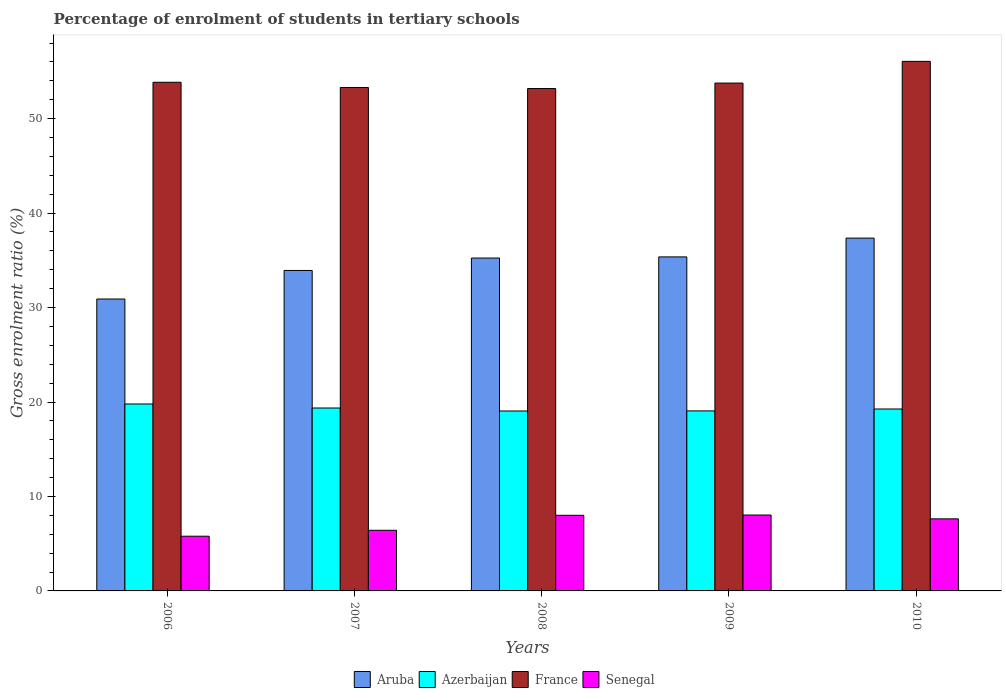How many different coloured bars are there?
Your answer should be compact. 4. How many groups of bars are there?
Offer a terse response. 5. Are the number of bars per tick equal to the number of legend labels?
Offer a very short reply. Yes. How many bars are there on the 1st tick from the left?
Give a very brief answer. 4. What is the label of the 5th group of bars from the left?
Your answer should be compact. 2010. In how many cases, is the number of bars for a given year not equal to the number of legend labels?
Your answer should be compact. 0. What is the percentage of students enrolled in tertiary schools in Senegal in 2008?
Your answer should be very brief. 8. Across all years, what is the maximum percentage of students enrolled in tertiary schools in Azerbaijan?
Your answer should be very brief. 19.79. Across all years, what is the minimum percentage of students enrolled in tertiary schools in Azerbaijan?
Offer a terse response. 19.05. What is the total percentage of students enrolled in tertiary schools in Aruba in the graph?
Make the answer very short. 172.78. What is the difference between the percentage of students enrolled in tertiary schools in Aruba in 2006 and that in 2008?
Provide a succinct answer. -4.34. What is the difference between the percentage of students enrolled in tertiary schools in Aruba in 2009 and the percentage of students enrolled in tertiary schools in Senegal in 2006?
Your response must be concise. 29.57. What is the average percentage of students enrolled in tertiary schools in Senegal per year?
Your answer should be very brief. 7.18. In the year 2007, what is the difference between the percentage of students enrolled in tertiary schools in Senegal and percentage of students enrolled in tertiary schools in France?
Provide a succinct answer. -46.88. What is the ratio of the percentage of students enrolled in tertiary schools in Azerbaijan in 2006 to that in 2007?
Provide a short and direct response. 1.02. Is the difference between the percentage of students enrolled in tertiary schools in Senegal in 2008 and 2009 greater than the difference between the percentage of students enrolled in tertiary schools in France in 2008 and 2009?
Ensure brevity in your answer.  Yes. What is the difference between the highest and the second highest percentage of students enrolled in tertiary schools in Aruba?
Your response must be concise. 1.99. What is the difference between the highest and the lowest percentage of students enrolled in tertiary schools in Aruba?
Keep it short and to the point. 6.45. In how many years, is the percentage of students enrolled in tertiary schools in Aruba greater than the average percentage of students enrolled in tertiary schools in Aruba taken over all years?
Keep it short and to the point. 3. Is the sum of the percentage of students enrolled in tertiary schools in Azerbaijan in 2009 and 2010 greater than the maximum percentage of students enrolled in tertiary schools in France across all years?
Offer a very short reply. No. What does the 4th bar from the left in 2008 represents?
Your answer should be compact. Senegal. What does the 4th bar from the right in 2010 represents?
Your answer should be very brief. Aruba. Is it the case that in every year, the sum of the percentage of students enrolled in tertiary schools in Azerbaijan and percentage of students enrolled in tertiary schools in France is greater than the percentage of students enrolled in tertiary schools in Aruba?
Your answer should be compact. Yes. Are all the bars in the graph horizontal?
Offer a terse response. No. What is the difference between two consecutive major ticks on the Y-axis?
Make the answer very short. 10. Are the values on the major ticks of Y-axis written in scientific E-notation?
Offer a terse response. No. Does the graph contain any zero values?
Provide a short and direct response. No. Does the graph contain grids?
Make the answer very short. No. What is the title of the graph?
Provide a short and direct response. Percentage of enrolment of students in tertiary schools. What is the label or title of the X-axis?
Ensure brevity in your answer.  Years. What is the label or title of the Y-axis?
Give a very brief answer. Gross enrolment ratio (%). What is the Gross enrolment ratio (%) in Aruba in 2006?
Give a very brief answer. 30.9. What is the Gross enrolment ratio (%) in Azerbaijan in 2006?
Provide a succinct answer. 19.79. What is the Gross enrolment ratio (%) of France in 2006?
Offer a terse response. 53.85. What is the Gross enrolment ratio (%) in Senegal in 2006?
Your answer should be very brief. 5.79. What is the Gross enrolment ratio (%) of Aruba in 2007?
Offer a very short reply. 33.93. What is the Gross enrolment ratio (%) of Azerbaijan in 2007?
Make the answer very short. 19.36. What is the Gross enrolment ratio (%) in France in 2007?
Keep it short and to the point. 53.3. What is the Gross enrolment ratio (%) in Senegal in 2007?
Keep it short and to the point. 6.42. What is the Gross enrolment ratio (%) of Aruba in 2008?
Provide a succinct answer. 35.24. What is the Gross enrolment ratio (%) in Azerbaijan in 2008?
Provide a short and direct response. 19.05. What is the Gross enrolment ratio (%) in France in 2008?
Make the answer very short. 53.19. What is the Gross enrolment ratio (%) of Senegal in 2008?
Offer a very short reply. 8. What is the Gross enrolment ratio (%) in Aruba in 2009?
Offer a very short reply. 35.36. What is the Gross enrolment ratio (%) in Azerbaijan in 2009?
Make the answer very short. 19.06. What is the Gross enrolment ratio (%) of France in 2009?
Make the answer very short. 53.76. What is the Gross enrolment ratio (%) in Senegal in 2009?
Provide a short and direct response. 8.04. What is the Gross enrolment ratio (%) of Aruba in 2010?
Give a very brief answer. 37.35. What is the Gross enrolment ratio (%) of Azerbaijan in 2010?
Offer a terse response. 19.26. What is the Gross enrolment ratio (%) in France in 2010?
Give a very brief answer. 56.06. What is the Gross enrolment ratio (%) of Senegal in 2010?
Give a very brief answer. 7.63. Across all years, what is the maximum Gross enrolment ratio (%) of Aruba?
Your response must be concise. 37.35. Across all years, what is the maximum Gross enrolment ratio (%) of Azerbaijan?
Provide a succinct answer. 19.79. Across all years, what is the maximum Gross enrolment ratio (%) of France?
Provide a short and direct response. 56.06. Across all years, what is the maximum Gross enrolment ratio (%) of Senegal?
Give a very brief answer. 8.04. Across all years, what is the minimum Gross enrolment ratio (%) of Aruba?
Your answer should be very brief. 30.9. Across all years, what is the minimum Gross enrolment ratio (%) of Azerbaijan?
Provide a short and direct response. 19.05. Across all years, what is the minimum Gross enrolment ratio (%) in France?
Keep it short and to the point. 53.19. Across all years, what is the minimum Gross enrolment ratio (%) in Senegal?
Provide a short and direct response. 5.79. What is the total Gross enrolment ratio (%) of Aruba in the graph?
Offer a very short reply. 172.78. What is the total Gross enrolment ratio (%) in Azerbaijan in the graph?
Offer a terse response. 96.52. What is the total Gross enrolment ratio (%) in France in the graph?
Provide a succinct answer. 270.16. What is the total Gross enrolment ratio (%) of Senegal in the graph?
Your answer should be very brief. 35.88. What is the difference between the Gross enrolment ratio (%) in Aruba in 2006 and that in 2007?
Your response must be concise. -3.02. What is the difference between the Gross enrolment ratio (%) in Azerbaijan in 2006 and that in 2007?
Your response must be concise. 0.42. What is the difference between the Gross enrolment ratio (%) of France in 2006 and that in 2007?
Provide a short and direct response. 0.55. What is the difference between the Gross enrolment ratio (%) in Senegal in 2006 and that in 2007?
Provide a succinct answer. -0.63. What is the difference between the Gross enrolment ratio (%) of Aruba in 2006 and that in 2008?
Offer a terse response. -4.34. What is the difference between the Gross enrolment ratio (%) of Azerbaijan in 2006 and that in 2008?
Provide a succinct answer. 0.74. What is the difference between the Gross enrolment ratio (%) of France in 2006 and that in 2008?
Make the answer very short. 0.66. What is the difference between the Gross enrolment ratio (%) in Senegal in 2006 and that in 2008?
Offer a very short reply. -2.21. What is the difference between the Gross enrolment ratio (%) of Aruba in 2006 and that in 2009?
Provide a short and direct response. -4.46. What is the difference between the Gross enrolment ratio (%) in Azerbaijan in 2006 and that in 2009?
Provide a succinct answer. 0.73. What is the difference between the Gross enrolment ratio (%) in France in 2006 and that in 2009?
Offer a very short reply. 0.08. What is the difference between the Gross enrolment ratio (%) of Senegal in 2006 and that in 2009?
Provide a short and direct response. -2.24. What is the difference between the Gross enrolment ratio (%) in Aruba in 2006 and that in 2010?
Provide a succinct answer. -6.45. What is the difference between the Gross enrolment ratio (%) of Azerbaijan in 2006 and that in 2010?
Your answer should be very brief. 0.53. What is the difference between the Gross enrolment ratio (%) of France in 2006 and that in 2010?
Your response must be concise. -2.21. What is the difference between the Gross enrolment ratio (%) in Senegal in 2006 and that in 2010?
Provide a short and direct response. -1.84. What is the difference between the Gross enrolment ratio (%) in Aruba in 2007 and that in 2008?
Make the answer very short. -1.31. What is the difference between the Gross enrolment ratio (%) in Azerbaijan in 2007 and that in 2008?
Your answer should be compact. 0.32. What is the difference between the Gross enrolment ratio (%) in France in 2007 and that in 2008?
Offer a terse response. 0.11. What is the difference between the Gross enrolment ratio (%) in Senegal in 2007 and that in 2008?
Give a very brief answer. -1.59. What is the difference between the Gross enrolment ratio (%) in Aruba in 2007 and that in 2009?
Make the answer very short. -1.44. What is the difference between the Gross enrolment ratio (%) in Azerbaijan in 2007 and that in 2009?
Your answer should be compact. 0.31. What is the difference between the Gross enrolment ratio (%) in France in 2007 and that in 2009?
Your answer should be very brief. -0.47. What is the difference between the Gross enrolment ratio (%) in Senegal in 2007 and that in 2009?
Your answer should be compact. -1.62. What is the difference between the Gross enrolment ratio (%) in Aruba in 2007 and that in 2010?
Your answer should be very brief. -3.43. What is the difference between the Gross enrolment ratio (%) of Azerbaijan in 2007 and that in 2010?
Keep it short and to the point. 0.1. What is the difference between the Gross enrolment ratio (%) in France in 2007 and that in 2010?
Keep it short and to the point. -2.77. What is the difference between the Gross enrolment ratio (%) in Senegal in 2007 and that in 2010?
Offer a very short reply. -1.21. What is the difference between the Gross enrolment ratio (%) of Aruba in 2008 and that in 2009?
Offer a terse response. -0.12. What is the difference between the Gross enrolment ratio (%) of Azerbaijan in 2008 and that in 2009?
Offer a very short reply. -0.01. What is the difference between the Gross enrolment ratio (%) in France in 2008 and that in 2009?
Provide a succinct answer. -0.58. What is the difference between the Gross enrolment ratio (%) of Senegal in 2008 and that in 2009?
Your answer should be compact. -0.03. What is the difference between the Gross enrolment ratio (%) in Aruba in 2008 and that in 2010?
Your answer should be compact. -2.11. What is the difference between the Gross enrolment ratio (%) in Azerbaijan in 2008 and that in 2010?
Provide a succinct answer. -0.21. What is the difference between the Gross enrolment ratio (%) in France in 2008 and that in 2010?
Provide a succinct answer. -2.88. What is the difference between the Gross enrolment ratio (%) of Senegal in 2008 and that in 2010?
Your answer should be very brief. 0.37. What is the difference between the Gross enrolment ratio (%) in Aruba in 2009 and that in 2010?
Provide a short and direct response. -1.99. What is the difference between the Gross enrolment ratio (%) in Azerbaijan in 2009 and that in 2010?
Your response must be concise. -0.2. What is the difference between the Gross enrolment ratio (%) in France in 2009 and that in 2010?
Keep it short and to the point. -2.3. What is the difference between the Gross enrolment ratio (%) of Senegal in 2009 and that in 2010?
Ensure brevity in your answer.  0.41. What is the difference between the Gross enrolment ratio (%) of Aruba in 2006 and the Gross enrolment ratio (%) of Azerbaijan in 2007?
Keep it short and to the point. 11.54. What is the difference between the Gross enrolment ratio (%) in Aruba in 2006 and the Gross enrolment ratio (%) in France in 2007?
Ensure brevity in your answer.  -22.39. What is the difference between the Gross enrolment ratio (%) in Aruba in 2006 and the Gross enrolment ratio (%) in Senegal in 2007?
Keep it short and to the point. 24.48. What is the difference between the Gross enrolment ratio (%) of Azerbaijan in 2006 and the Gross enrolment ratio (%) of France in 2007?
Provide a short and direct response. -33.51. What is the difference between the Gross enrolment ratio (%) in Azerbaijan in 2006 and the Gross enrolment ratio (%) in Senegal in 2007?
Ensure brevity in your answer.  13.37. What is the difference between the Gross enrolment ratio (%) in France in 2006 and the Gross enrolment ratio (%) in Senegal in 2007?
Your answer should be very brief. 47.43. What is the difference between the Gross enrolment ratio (%) of Aruba in 2006 and the Gross enrolment ratio (%) of Azerbaijan in 2008?
Provide a short and direct response. 11.86. What is the difference between the Gross enrolment ratio (%) in Aruba in 2006 and the Gross enrolment ratio (%) in France in 2008?
Ensure brevity in your answer.  -22.28. What is the difference between the Gross enrolment ratio (%) in Aruba in 2006 and the Gross enrolment ratio (%) in Senegal in 2008?
Keep it short and to the point. 22.9. What is the difference between the Gross enrolment ratio (%) of Azerbaijan in 2006 and the Gross enrolment ratio (%) of France in 2008?
Offer a very short reply. -33.4. What is the difference between the Gross enrolment ratio (%) in Azerbaijan in 2006 and the Gross enrolment ratio (%) in Senegal in 2008?
Your response must be concise. 11.78. What is the difference between the Gross enrolment ratio (%) of France in 2006 and the Gross enrolment ratio (%) of Senegal in 2008?
Your response must be concise. 45.84. What is the difference between the Gross enrolment ratio (%) of Aruba in 2006 and the Gross enrolment ratio (%) of Azerbaijan in 2009?
Your response must be concise. 11.85. What is the difference between the Gross enrolment ratio (%) in Aruba in 2006 and the Gross enrolment ratio (%) in France in 2009?
Offer a very short reply. -22.86. What is the difference between the Gross enrolment ratio (%) in Aruba in 2006 and the Gross enrolment ratio (%) in Senegal in 2009?
Provide a succinct answer. 22.87. What is the difference between the Gross enrolment ratio (%) in Azerbaijan in 2006 and the Gross enrolment ratio (%) in France in 2009?
Give a very brief answer. -33.97. What is the difference between the Gross enrolment ratio (%) in Azerbaijan in 2006 and the Gross enrolment ratio (%) in Senegal in 2009?
Provide a succinct answer. 11.75. What is the difference between the Gross enrolment ratio (%) in France in 2006 and the Gross enrolment ratio (%) in Senegal in 2009?
Give a very brief answer. 45.81. What is the difference between the Gross enrolment ratio (%) of Aruba in 2006 and the Gross enrolment ratio (%) of Azerbaijan in 2010?
Your answer should be very brief. 11.64. What is the difference between the Gross enrolment ratio (%) of Aruba in 2006 and the Gross enrolment ratio (%) of France in 2010?
Keep it short and to the point. -25.16. What is the difference between the Gross enrolment ratio (%) of Aruba in 2006 and the Gross enrolment ratio (%) of Senegal in 2010?
Make the answer very short. 23.27. What is the difference between the Gross enrolment ratio (%) in Azerbaijan in 2006 and the Gross enrolment ratio (%) in France in 2010?
Provide a short and direct response. -36.27. What is the difference between the Gross enrolment ratio (%) in Azerbaijan in 2006 and the Gross enrolment ratio (%) in Senegal in 2010?
Give a very brief answer. 12.16. What is the difference between the Gross enrolment ratio (%) of France in 2006 and the Gross enrolment ratio (%) of Senegal in 2010?
Your answer should be compact. 46.22. What is the difference between the Gross enrolment ratio (%) in Aruba in 2007 and the Gross enrolment ratio (%) in Azerbaijan in 2008?
Your answer should be compact. 14.88. What is the difference between the Gross enrolment ratio (%) of Aruba in 2007 and the Gross enrolment ratio (%) of France in 2008?
Your response must be concise. -19.26. What is the difference between the Gross enrolment ratio (%) in Aruba in 2007 and the Gross enrolment ratio (%) in Senegal in 2008?
Your answer should be compact. 25.92. What is the difference between the Gross enrolment ratio (%) in Azerbaijan in 2007 and the Gross enrolment ratio (%) in France in 2008?
Your answer should be very brief. -33.82. What is the difference between the Gross enrolment ratio (%) in Azerbaijan in 2007 and the Gross enrolment ratio (%) in Senegal in 2008?
Your answer should be compact. 11.36. What is the difference between the Gross enrolment ratio (%) in France in 2007 and the Gross enrolment ratio (%) in Senegal in 2008?
Your answer should be compact. 45.29. What is the difference between the Gross enrolment ratio (%) in Aruba in 2007 and the Gross enrolment ratio (%) in Azerbaijan in 2009?
Ensure brevity in your answer.  14.87. What is the difference between the Gross enrolment ratio (%) in Aruba in 2007 and the Gross enrolment ratio (%) in France in 2009?
Your response must be concise. -19.84. What is the difference between the Gross enrolment ratio (%) in Aruba in 2007 and the Gross enrolment ratio (%) in Senegal in 2009?
Your response must be concise. 25.89. What is the difference between the Gross enrolment ratio (%) in Azerbaijan in 2007 and the Gross enrolment ratio (%) in France in 2009?
Offer a very short reply. -34.4. What is the difference between the Gross enrolment ratio (%) in Azerbaijan in 2007 and the Gross enrolment ratio (%) in Senegal in 2009?
Your answer should be compact. 11.33. What is the difference between the Gross enrolment ratio (%) of France in 2007 and the Gross enrolment ratio (%) of Senegal in 2009?
Ensure brevity in your answer.  45.26. What is the difference between the Gross enrolment ratio (%) in Aruba in 2007 and the Gross enrolment ratio (%) in Azerbaijan in 2010?
Make the answer very short. 14.67. What is the difference between the Gross enrolment ratio (%) of Aruba in 2007 and the Gross enrolment ratio (%) of France in 2010?
Your response must be concise. -22.14. What is the difference between the Gross enrolment ratio (%) in Aruba in 2007 and the Gross enrolment ratio (%) in Senegal in 2010?
Give a very brief answer. 26.3. What is the difference between the Gross enrolment ratio (%) in Azerbaijan in 2007 and the Gross enrolment ratio (%) in France in 2010?
Offer a very short reply. -36.7. What is the difference between the Gross enrolment ratio (%) of Azerbaijan in 2007 and the Gross enrolment ratio (%) of Senegal in 2010?
Your response must be concise. 11.73. What is the difference between the Gross enrolment ratio (%) in France in 2007 and the Gross enrolment ratio (%) in Senegal in 2010?
Offer a terse response. 45.67. What is the difference between the Gross enrolment ratio (%) of Aruba in 2008 and the Gross enrolment ratio (%) of Azerbaijan in 2009?
Ensure brevity in your answer.  16.18. What is the difference between the Gross enrolment ratio (%) of Aruba in 2008 and the Gross enrolment ratio (%) of France in 2009?
Your answer should be compact. -18.52. What is the difference between the Gross enrolment ratio (%) of Aruba in 2008 and the Gross enrolment ratio (%) of Senegal in 2009?
Keep it short and to the point. 27.2. What is the difference between the Gross enrolment ratio (%) in Azerbaijan in 2008 and the Gross enrolment ratio (%) in France in 2009?
Offer a very short reply. -34.72. What is the difference between the Gross enrolment ratio (%) in Azerbaijan in 2008 and the Gross enrolment ratio (%) in Senegal in 2009?
Keep it short and to the point. 11.01. What is the difference between the Gross enrolment ratio (%) of France in 2008 and the Gross enrolment ratio (%) of Senegal in 2009?
Offer a terse response. 45.15. What is the difference between the Gross enrolment ratio (%) in Aruba in 2008 and the Gross enrolment ratio (%) in Azerbaijan in 2010?
Make the answer very short. 15.98. What is the difference between the Gross enrolment ratio (%) in Aruba in 2008 and the Gross enrolment ratio (%) in France in 2010?
Make the answer very short. -20.82. What is the difference between the Gross enrolment ratio (%) of Aruba in 2008 and the Gross enrolment ratio (%) of Senegal in 2010?
Your answer should be compact. 27.61. What is the difference between the Gross enrolment ratio (%) of Azerbaijan in 2008 and the Gross enrolment ratio (%) of France in 2010?
Offer a terse response. -37.02. What is the difference between the Gross enrolment ratio (%) in Azerbaijan in 2008 and the Gross enrolment ratio (%) in Senegal in 2010?
Provide a short and direct response. 11.42. What is the difference between the Gross enrolment ratio (%) in France in 2008 and the Gross enrolment ratio (%) in Senegal in 2010?
Provide a succinct answer. 45.56. What is the difference between the Gross enrolment ratio (%) in Aruba in 2009 and the Gross enrolment ratio (%) in Azerbaijan in 2010?
Your answer should be very brief. 16.1. What is the difference between the Gross enrolment ratio (%) in Aruba in 2009 and the Gross enrolment ratio (%) in France in 2010?
Your response must be concise. -20.7. What is the difference between the Gross enrolment ratio (%) of Aruba in 2009 and the Gross enrolment ratio (%) of Senegal in 2010?
Offer a very short reply. 27.73. What is the difference between the Gross enrolment ratio (%) in Azerbaijan in 2009 and the Gross enrolment ratio (%) in France in 2010?
Keep it short and to the point. -37.01. What is the difference between the Gross enrolment ratio (%) of Azerbaijan in 2009 and the Gross enrolment ratio (%) of Senegal in 2010?
Offer a terse response. 11.43. What is the difference between the Gross enrolment ratio (%) of France in 2009 and the Gross enrolment ratio (%) of Senegal in 2010?
Your answer should be compact. 46.13. What is the average Gross enrolment ratio (%) in Aruba per year?
Provide a succinct answer. 34.56. What is the average Gross enrolment ratio (%) in Azerbaijan per year?
Provide a succinct answer. 19.3. What is the average Gross enrolment ratio (%) of France per year?
Offer a very short reply. 54.03. What is the average Gross enrolment ratio (%) of Senegal per year?
Offer a terse response. 7.18. In the year 2006, what is the difference between the Gross enrolment ratio (%) in Aruba and Gross enrolment ratio (%) in Azerbaijan?
Provide a short and direct response. 11.11. In the year 2006, what is the difference between the Gross enrolment ratio (%) in Aruba and Gross enrolment ratio (%) in France?
Ensure brevity in your answer.  -22.95. In the year 2006, what is the difference between the Gross enrolment ratio (%) of Aruba and Gross enrolment ratio (%) of Senegal?
Provide a short and direct response. 25.11. In the year 2006, what is the difference between the Gross enrolment ratio (%) in Azerbaijan and Gross enrolment ratio (%) in France?
Ensure brevity in your answer.  -34.06. In the year 2006, what is the difference between the Gross enrolment ratio (%) of Azerbaijan and Gross enrolment ratio (%) of Senegal?
Your response must be concise. 14. In the year 2006, what is the difference between the Gross enrolment ratio (%) in France and Gross enrolment ratio (%) in Senegal?
Your answer should be compact. 48.06. In the year 2007, what is the difference between the Gross enrolment ratio (%) of Aruba and Gross enrolment ratio (%) of Azerbaijan?
Provide a short and direct response. 14.56. In the year 2007, what is the difference between the Gross enrolment ratio (%) of Aruba and Gross enrolment ratio (%) of France?
Give a very brief answer. -19.37. In the year 2007, what is the difference between the Gross enrolment ratio (%) in Aruba and Gross enrolment ratio (%) in Senegal?
Offer a very short reply. 27.51. In the year 2007, what is the difference between the Gross enrolment ratio (%) of Azerbaijan and Gross enrolment ratio (%) of France?
Keep it short and to the point. -33.93. In the year 2007, what is the difference between the Gross enrolment ratio (%) in Azerbaijan and Gross enrolment ratio (%) in Senegal?
Offer a very short reply. 12.95. In the year 2007, what is the difference between the Gross enrolment ratio (%) in France and Gross enrolment ratio (%) in Senegal?
Offer a very short reply. 46.88. In the year 2008, what is the difference between the Gross enrolment ratio (%) of Aruba and Gross enrolment ratio (%) of Azerbaijan?
Make the answer very short. 16.19. In the year 2008, what is the difference between the Gross enrolment ratio (%) of Aruba and Gross enrolment ratio (%) of France?
Provide a short and direct response. -17.95. In the year 2008, what is the difference between the Gross enrolment ratio (%) of Aruba and Gross enrolment ratio (%) of Senegal?
Offer a terse response. 27.24. In the year 2008, what is the difference between the Gross enrolment ratio (%) in Azerbaijan and Gross enrolment ratio (%) in France?
Give a very brief answer. -34.14. In the year 2008, what is the difference between the Gross enrolment ratio (%) in Azerbaijan and Gross enrolment ratio (%) in Senegal?
Your answer should be very brief. 11.04. In the year 2008, what is the difference between the Gross enrolment ratio (%) in France and Gross enrolment ratio (%) in Senegal?
Your answer should be compact. 45.18. In the year 2009, what is the difference between the Gross enrolment ratio (%) in Aruba and Gross enrolment ratio (%) in Azerbaijan?
Keep it short and to the point. 16.3. In the year 2009, what is the difference between the Gross enrolment ratio (%) of Aruba and Gross enrolment ratio (%) of France?
Offer a very short reply. -18.4. In the year 2009, what is the difference between the Gross enrolment ratio (%) of Aruba and Gross enrolment ratio (%) of Senegal?
Offer a very short reply. 27.33. In the year 2009, what is the difference between the Gross enrolment ratio (%) of Azerbaijan and Gross enrolment ratio (%) of France?
Offer a very short reply. -34.71. In the year 2009, what is the difference between the Gross enrolment ratio (%) of Azerbaijan and Gross enrolment ratio (%) of Senegal?
Ensure brevity in your answer.  11.02. In the year 2009, what is the difference between the Gross enrolment ratio (%) of France and Gross enrolment ratio (%) of Senegal?
Offer a very short reply. 45.73. In the year 2010, what is the difference between the Gross enrolment ratio (%) in Aruba and Gross enrolment ratio (%) in Azerbaijan?
Offer a terse response. 18.09. In the year 2010, what is the difference between the Gross enrolment ratio (%) in Aruba and Gross enrolment ratio (%) in France?
Your answer should be very brief. -18.71. In the year 2010, what is the difference between the Gross enrolment ratio (%) of Aruba and Gross enrolment ratio (%) of Senegal?
Ensure brevity in your answer.  29.72. In the year 2010, what is the difference between the Gross enrolment ratio (%) of Azerbaijan and Gross enrolment ratio (%) of France?
Provide a short and direct response. -36.8. In the year 2010, what is the difference between the Gross enrolment ratio (%) of Azerbaijan and Gross enrolment ratio (%) of Senegal?
Give a very brief answer. 11.63. In the year 2010, what is the difference between the Gross enrolment ratio (%) in France and Gross enrolment ratio (%) in Senegal?
Offer a very short reply. 48.43. What is the ratio of the Gross enrolment ratio (%) of Aruba in 2006 to that in 2007?
Give a very brief answer. 0.91. What is the ratio of the Gross enrolment ratio (%) in Azerbaijan in 2006 to that in 2007?
Your answer should be very brief. 1.02. What is the ratio of the Gross enrolment ratio (%) in France in 2006 to that in 2007?
Ensure brevity in your answer.  1.01. What is the ratio of the Gross enrolment ratio (%) of Senegal in 2006 to that in 2007?
Offer a very short reply. 0.9. What is the ratio of the Gross enrolment ratio (%) of Aruba in 2006 to that in 2008?
Provide a succinct answer. 0.88. What is the ratio of the Gross enrolment ratio (%) of Azerbaijan in 2006 to that in 2008?
Give a very brief answer. 1.04. What is the ratio of the Gross enrolment ratio (%) of France in 2006 to that in 2008?
Provide a succinct answer. 1.01. What is the ratio of the Gross enrolment ratio (%) of Senegal in 2006 to that in 2008?
Your response must be concise. 0.72. What is the ratio of the Gross enrolment ratio (%) in Aruba in 2006 to that in 2009?
Your answer should be very brief. 0.87. What is the ratio of the Gross enrolment ratio (%) of Azerbaijan in 2006 to that in 2009?
Provide a short and direct response. 1.04. What is the ratio of the Gross enrolment ratio (%) of France in 2006 to that in 2009?
Offer a very short reply. 1. What is the ratio of the Gross enrolment ratio (%) in Senegal in 2006 to that in 2009?
Keep it short and to the point. 0.72. What is the ratio of the Gross enrolment ratio (%) in Aruba in 2006 to that in 2010?
Your answer should be compact. 0.83. What is the ratio of the Gross enrolment ratio (%) of Azerbaijan in 2006 to that in 2010?
Your answer should be compact. 1.03. What is the ratio of the Gross enrolment ratio (%) of France in 2006 to that in 2010?
Your response must be concise. 0.96. What is the ratio of the Gross enrolment ratio (%) in Senegal in 2006 to that in 2010?
Offer a very short reply. 0.76. What is the ratio of the Gross enrolment ratio (%) in Aruba in 2007 to that in 2008?
Give a very brief answer. 0.96. What is the ratio of the Gross enrolment ratio (%) in Azerbaijan in 2007 to that in 2008?
Make the answer very short. 1.02. What is the ratio of the Gross enrolment ratio (%) in Senegal in 2007 to that in 2008?
Offer a very short reply. 0.8. What is the ratio of the Gross enrolment ratio (%) in Aruba in 2007 to that in 2009?
Ensure brevity in your answer.  0.96. What is the ratio of the Gross enrolment ratio (%) in Azerbaijan in 2007 to that in 2009?
Provide a short and direct response. 1.02. What is the ratio of the Gross enrolment ratio (%) in Senegal in 2007 to that in 2009?
Your response must be concise. 0.8. What is the ratio of the Gross enrolment ratio (%) of Aruba in 2007 to that in 2010?
Keep it short and to the point. 0.91. What is the ratio of the Gross enrolment ratio (%) in Azerbaijan in 2007 to that in 2010?
Your answer should be very brief. 1.01. What is the ratio of the Gross enrolment ratio (%) of France in 2007 to that in 2010?
Provide a short and direct response. 0.95. What is the ratio of the Gross enrolment ratio (%) in Senegal in 2007 to that in 2010?
Provide a short and direct response. 0.84. What is the ratio of the Gross enrolment ratio (%) of Aruba in 2008 to that in 2009?
Offer a very short reply. 1. What is the ratio of the Gross enrolment ratio (%) of Azerbaijan in 2008 to that in 2009?
Give a very brief answer. 1. What is the ratio of the Gross enrolment ratio (%) in France in 2008 to that in 2009?
Your answer should be compact. 0.99. What is the ratio of the Gross enrolment ratio (%) in Aruba in 2008 to that in 2010?
Make the answer very short. 0.94. What is the ratio of the Gross enrolment ratio (%) of Azerbaijan in 2008 to that in 2010?
Give a very brief answer. 0.99. What is the ratio of the Gross enrolment ratio (%) in France in 2008 to that in 2010?
Provide a short and direct response. 0.95. What is the ratio of the Gross enrolment ratio (%) in Senegal in 2008 to that in 2010?
Offer a very short reply. 1.05. What is the ratio of the Gross enrolment ratio (%) of Aruba in 2009 to that in 2010?
Give a very brief answer. 0.95. What is the ratio of the Gross enrolment ratio (%) of Azerbaijan in 2009 to that in 2010?
Provide a short and direct response. 0.99. What is the ratio of the Gross enrolment ratio (%) in Senegal in 2009 to that in 2010?
Your answer should be compact. 1.05. What is the difference between the highest and the second highest Gross enrolment ratio (%) of Aruba?
Your response must be concise. 1.99. What is the difference between the highest and the second highest Gross enrolment ratio (%) of Azerbaijan?
Your response must be concise. 0.42. What is the difference between the highest and the second highest Gross enrolment ratio (%) in France?
Provide a short and direct response. 2.21. What is the difference between the highest and the second highest Gross enrolment ratio (%) of Senegal?
Provide a succinct answer. 0.03. What is the difference between the highest and the lowest Gross enrolment ratio (%) of Aruba?
Keep it short and to the point. 6.45. What is the difference between the highest and the lowest Gross enrolment ratio (%) in Azerbaijan?
Offer a very short reply. 0.74. What is the difference between the highest and the lowest Gross enrolment ratio (%) of France?
Provide a short and direct response. 2.88. What is the difference between the highest and the lowest Gross enrolment ratio (%) of Senegal?
Your response must be concise. 2.24. 